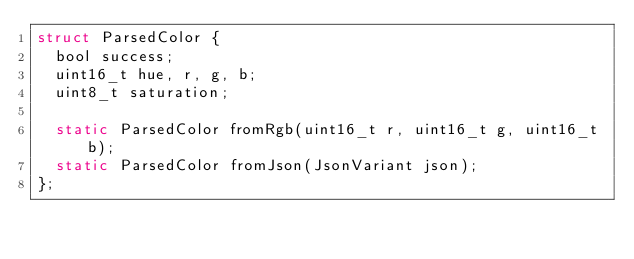Convert code to text. <code><loc_0><loc_0><loc_500><loc_500><_C_>struct ParsedColor {
  bool success;
  uint16_t hue, r, g, b;
  uint8_t saturation;

  static ParsedColor fromRgb(uint16_t r, uint16_t g, uint16_t b);
  static ParsedColor fromJson(JsonVariant json);
};</code> 